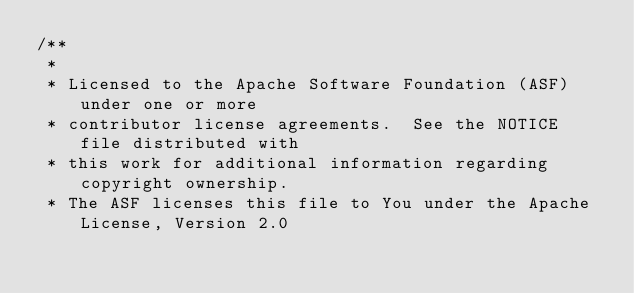Convert code to text. <code><loc_0><loc_0><loc_500><loc_500><_C++_>/**
 *
 * Licensed to the Apache Software Foundation (ASF) under one or more
 * contributor license agreements.  See the NOTICE file distributed with
 * this work for additional information regarding copyright ownership.
 * The ASF licenses this file to You under the Apache License, Version 2.0</code> 